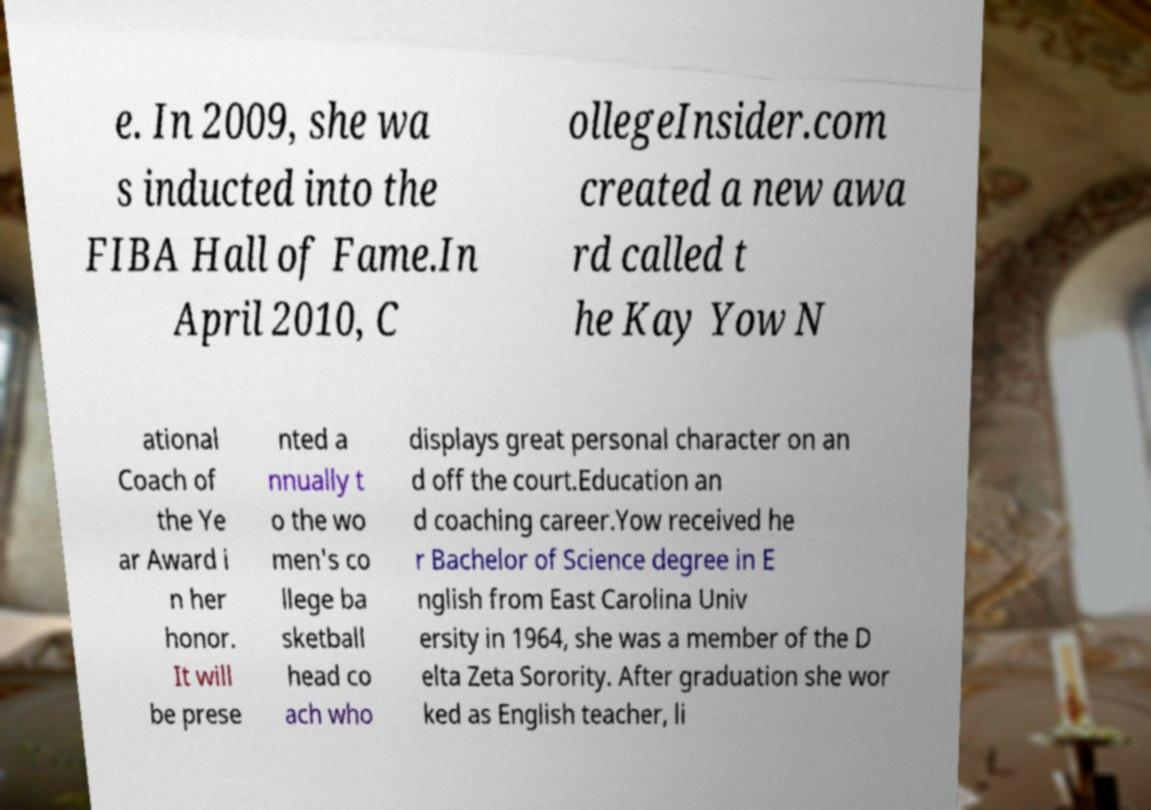Could you assist in decoding the text presented in this image and type it out clearly? e. In 2009, she wa s inducted into the FIBA Hall of Fame.In April 2010, C ollegeInsider.com created a new awa rd called t he Kay Yow N ational Coach of the Ye ar Award i n her honor. It will be prese nted a nnually t o the wo men's co llege ba sketball head co ach who displays great personal character on an d off the court.Education an d coaching career.Yow received he r Bachelor of Science degree in E nglish from East Carolina Univ ersity in 1964, she was a member of the D elta Zeta Sorority. After graduation she wor ked as English teacher, li 